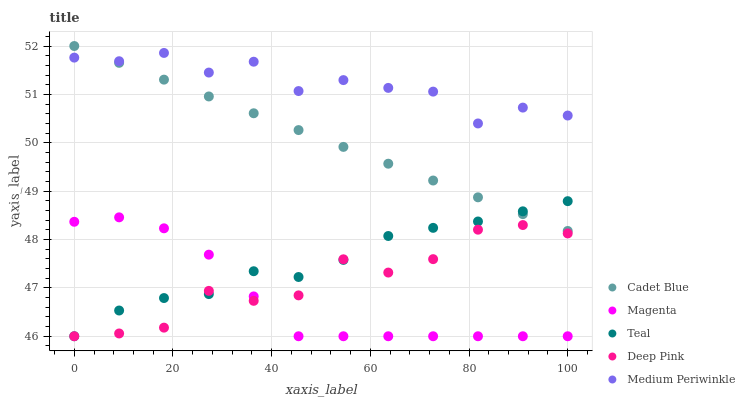Does Magenta have the minimum area under the curve?
Answer yes or no. Yes. Does Medium Periwinkle have the maximum area under the curve?
Answer yes or no. Yes. Does Cadet Blue have the minimum area under the curve?
Answer yes or no. No. Does Cadet Blue have the maximum area under the curve?
Answer yes or no. No. Is Cadet Blue the smoothest?
Answer yes or no. Yes. Is Medium Periwinkle the roughest?
Answer yes or no. Yes. Is Medium Periwinkle the smoothest?
Answer yes or no. No. Is Cadet Blue the roughest?
Answer yes or no. No. Does Magenta have the lowest value?
Answer yes or no. Yes. Does Cadet Blue have the lowest value?
Answer yes or no. No. Does Cadet Blue have the highest value?
Answer yes or no. Yes. Does Medium Periwinkle have the highest value?
Answer yes or no. No. Is Magenta less than Medium Periwinkle?
Answer yes or no. Yes. Is Cadet Blue greater than Deep Pink?
Answer yes or no. Yes. Does Magenta intersect Teal?
Answer yes or no. Yes. Is Magenta less than Teal?
Answer yes or no. No. Is Magenta greater than Teal?
Answer yes or no. No. Does Magenta intersect Medium Periwinkle?
Answer yes or no. No. 